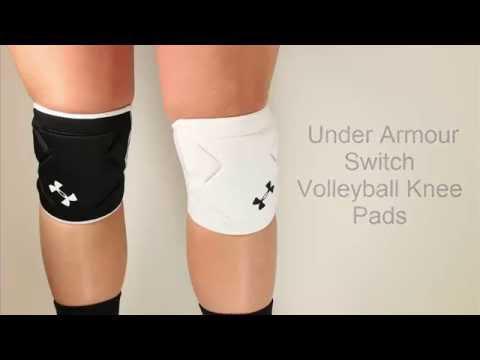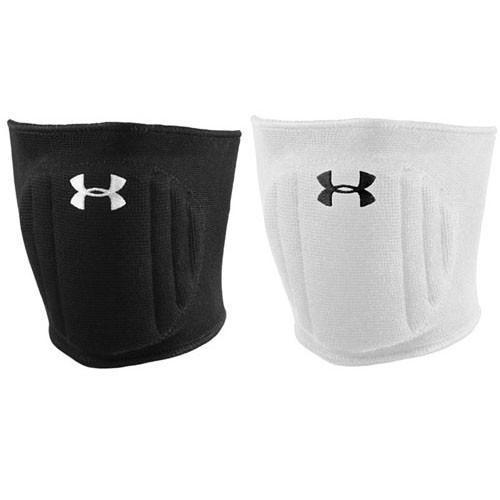The first image is the image on the left, the second image is the image on the right. Assess this claim about the two images: "The knee guards are being worn by a person in at least one of the images.". Correct or not? Answer yes or no. Yes. The first image is the image on the left, the second image is the image on the right. For the images displayed, is the sentence "One image features a pair of legs wearing knee pads, and the other image includes a white knee pad." factually correct? Answer yes or no. Yes. 